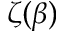Convert formula to latex. <formula><loc_0><loc_0><loc_500><loc_500>\zeta ( \beta )</formula> 